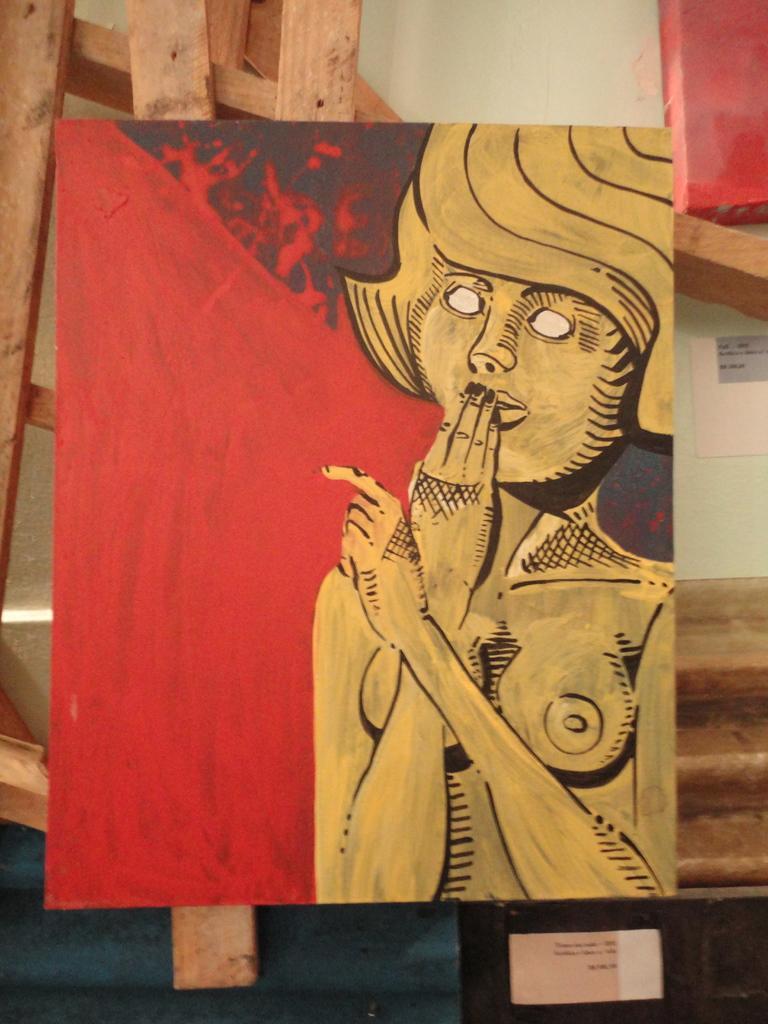Please provide a concise description of this image. In this picture there is a board in the foreground and there is a picture of a woman on the board. At the back there are wooden objects and there is a poster on the wall and there is text on the poster. 